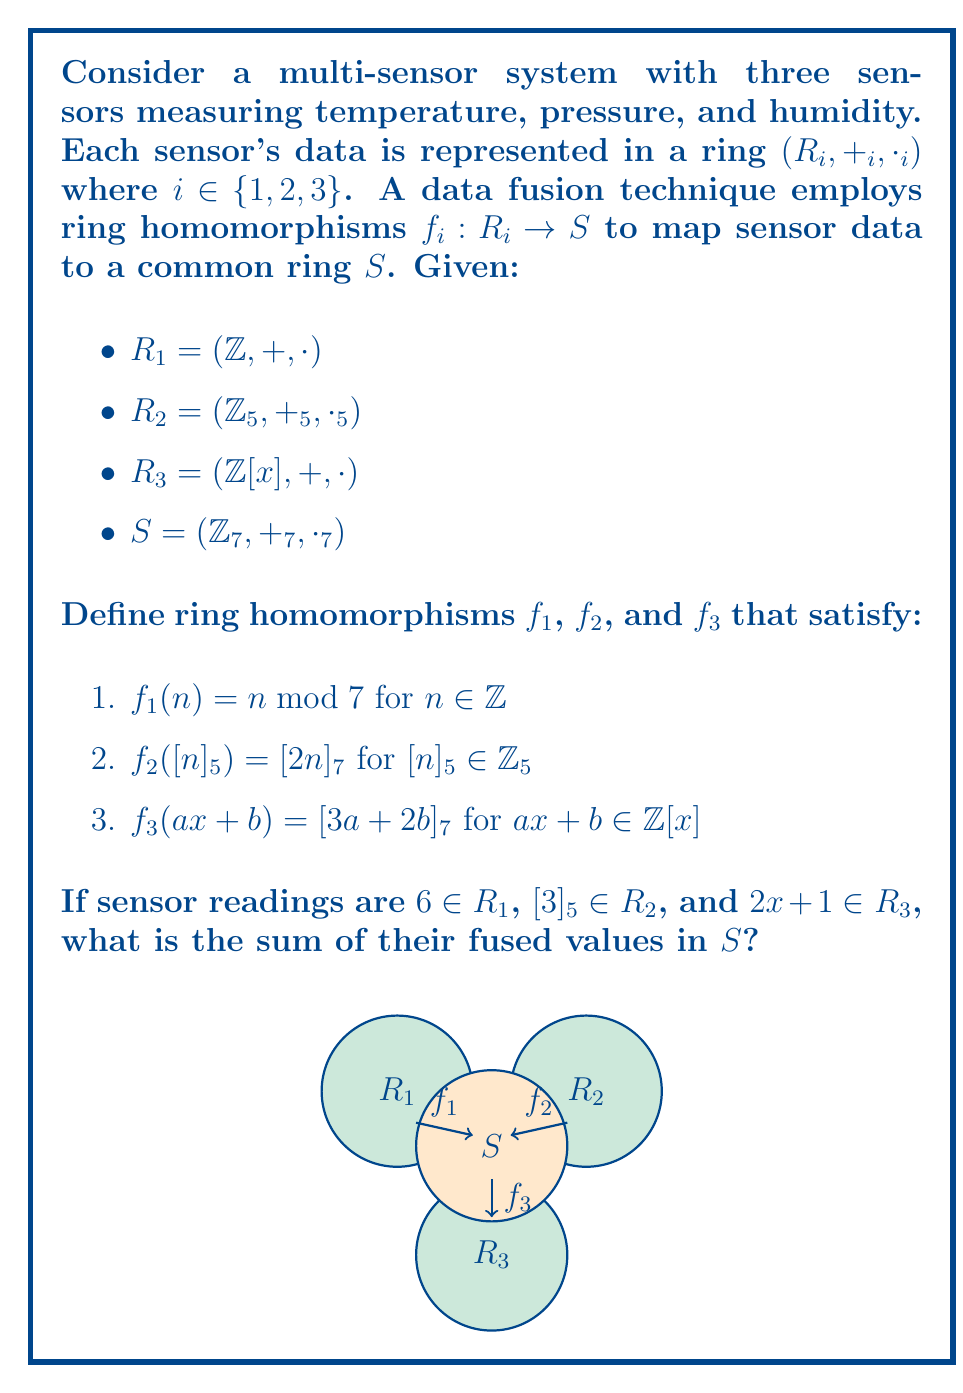Can you solve this math problem? Let's approach this step-by-step:

1. For $R_1$:
   The sensor reading is 6.
   $f_1(6) = 6 \bmod 7 = 6$

2. For $R_2$:
   The sensor reading is $[3]_5$.
   $f_2([3]_5) = [2 \cdot 3]_7 = [6]_7 = 6$

3. For $R_3$:
   The sensor reading is $2x + 1$.
   $f_3(2x + 1) = [3 \cdot 2 + 2 \cdot 1]_7 = [8]_7 = 1$

Now, we need to sum these values in $S = (\mathbb{Z}_7, +_7, \cdot_7)$:

$$6 +_7 6 +_7 1 = [13]_7 = 6$$

Therefore, the sum of the fused values in $S$ is 6.
Answer: 6 